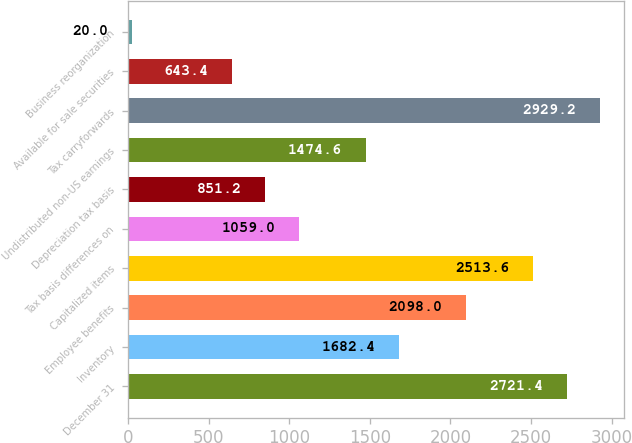Convert chart. <chart><loc_0><loc_0><loc_500><loc_500><bar_chart><fcel>December 31<fcel>Inventory<fcel>Employee benefits<fcel>Capitalized items<fcel>Tax basis differences on<fcel>Depreciation tax basis<fcel>Undistributed non-US earnings<fcel>Tax carryforwards<fcel>Available for sale securities<fcel>Business reorganization<nl><fcel>2721.4<fcel>1682.4<fcel>2098<fcel>2513.6<fcel>1059<fcel>851.2<fcel>1474.6<fcel>2929.2<fcel>643.4<fcel>20<nl></chart> 